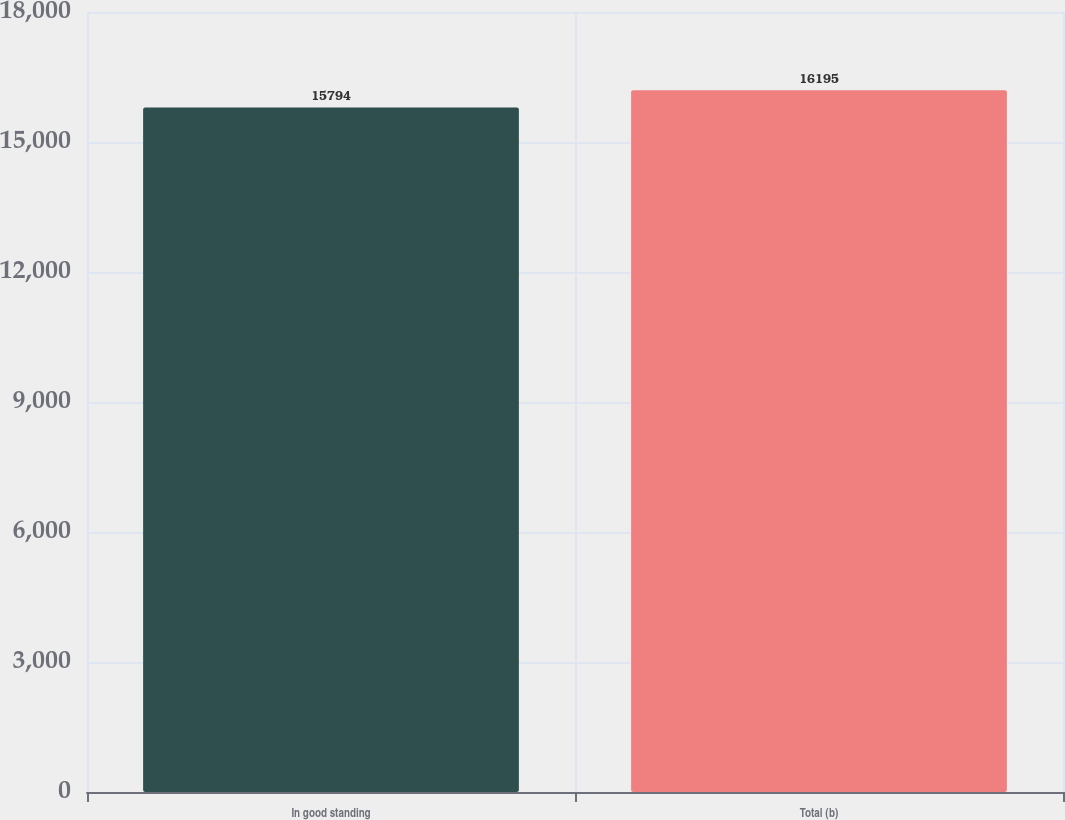<chart> <loc_0><loc_0><loc_500><loc_500><bar_chart><fcel>In good standing<fcel>Total (b)<nl><fcel>15794<fcel>16195<nl></chart> 